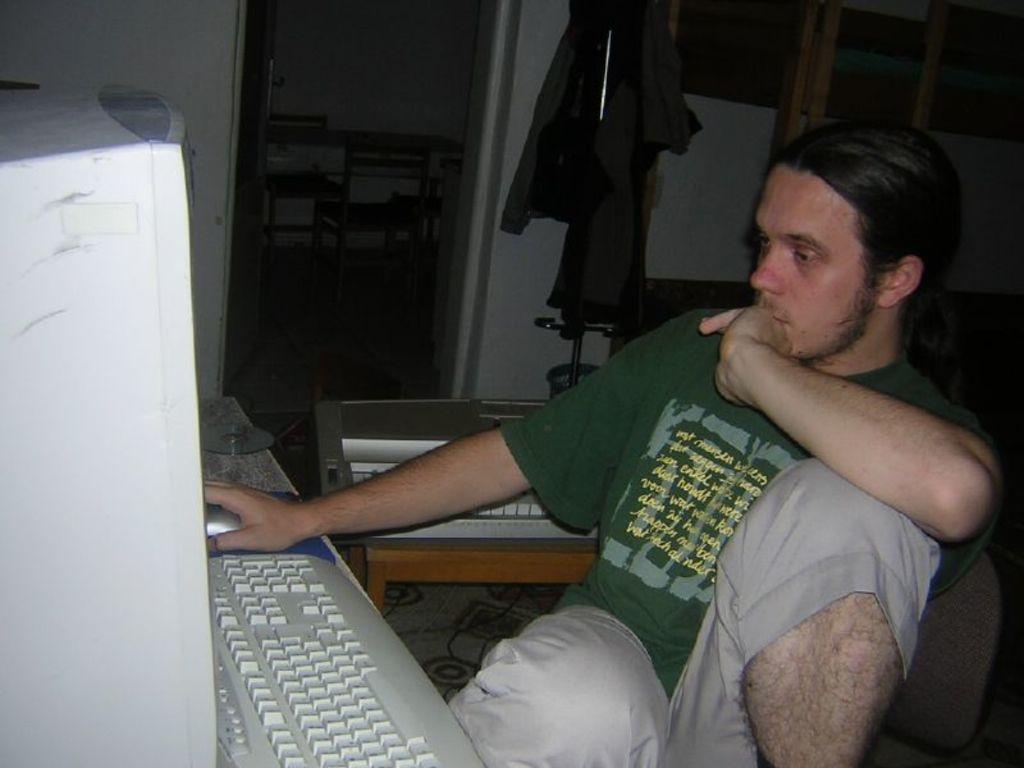Describe this image in one or two sentences. In this picture we can see a man sitting on a chair in front of a table, we can see a monitor, a keyboard, a mouse and a disc present on the table, in the background there is a wall, we can see clothes here, in the middle there are two chairs and a table. 